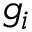<formula> <loc_0><loc_0><loc_500><loc_500>g _ { i }</formula> 